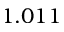Convert formula to latex. <formula><loc_0><loc_0><loc_500><loc_500>1 . 0 1 1</formula> 